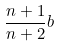<formula> <loc_0><loc_0><loc_500><loc_500>\frac { n + 1 } { n + 2 } b</formula> 